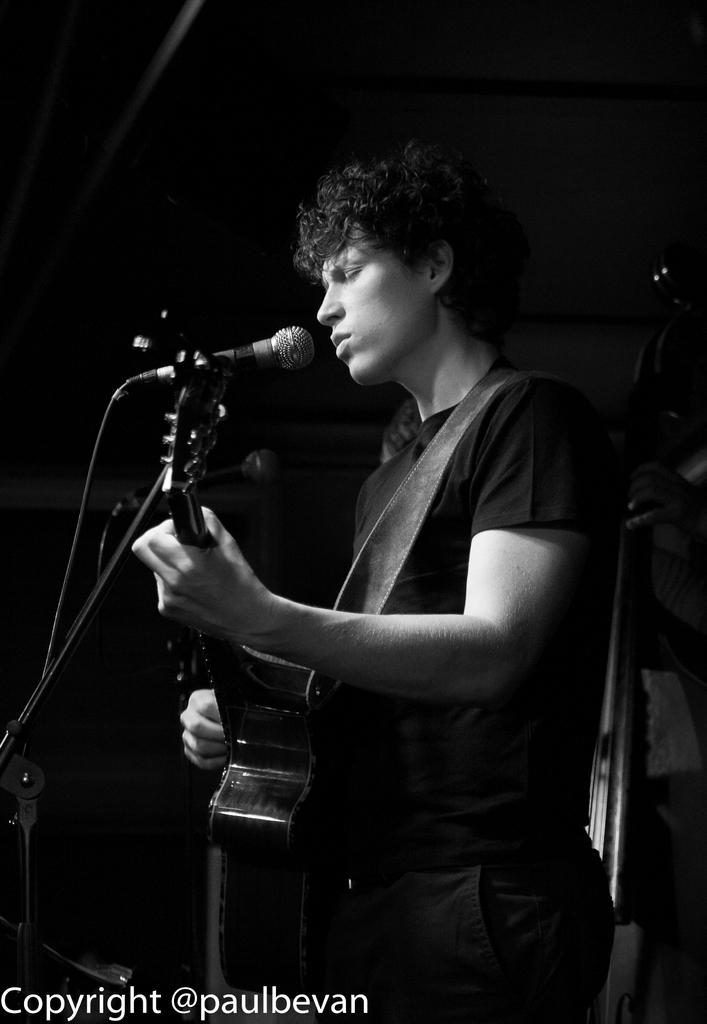What is the man in the image holding? The man is holding a guitar. What position is the man in within the image? The man is standing. What object is near the man in the image? The man is near a microphone (mic). How many dinosaurs are visible in the image? There are no dinosaurs present in the image. What type of stem is the man holding in the image? The man is not holding a stem in the image; he is holding a guitar. 